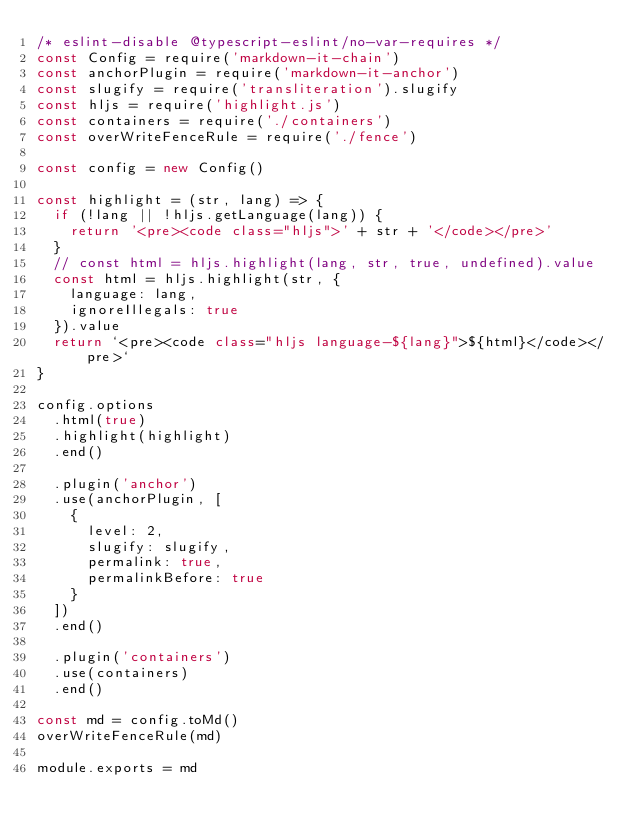Convert code to text. <code><loc_0><loc_0><loc_500><loc_500><_JavaScript_>/* eslint-disable @typescript-eslint/no-var-requires */
const Config = require('markdown-it-chain')
const anchorPlugin = require('markdown-it-anchor')
const slugify = require('transliteration').slugify
const hljs = require('highlight.js')
const containers = require('./containers')
const overWriteFenceRule = require('./fence')

const config = new Config()

const highlight = (str, lang) => {
  if (!lang || !hljs.getLanguage(lang)) {
    return '<pre><code class="hljs">' + str + '</code></pre>'
  }
  // const html = hljs.highlight(lang, str, true, undefined).value
  const html = hljs.highlight(str, {
    language: lang,
    ignoreIllegals: true
  }).value
  return `<pre><code class="hljs language-${lang}">${html}</code></pre>`
}

config.options
  .html(true)
  .highlight(highlight)
  .end()

  .plugin('anchor')
  .use(anchorPlugin, [
    {
      level: 2,
      slugify: slugify,
      permalink: true,
      permalinkBefore: true
    }
  ])
  .end()

  .plugin('containers')
  .use(containers)
  .end()

const md = config.toMd()
overWriteFenceRule(md)

module.exports = md
</code> 